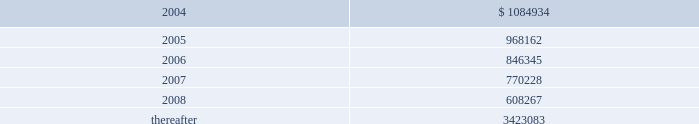Vornado realty trust 77 cash flows the company expects to contribute $ 959000 to the plans in 2004 .
11 .
Leases as lessor : the company leases space to tenants under operating leases .
Most of the leases provide for the payment of fixed base rentals payable monthly in advance .
Shopping center leases provide for the pass-through to tenants of real estate taxes , insurance and maintenance .
Office building leases generally require the tenants to reimburse the company for operating costs and real estate taxes above their base year costs .
Shopping center leases also provide for the payment by the lessee of additional rent based on a percentage of the tenants 2019 sales .
As of december 31 , 2003 , future base rental revenue under non-cancelable operating leases , excluding rents for leases with an original term of less than one year and rents resulting from the exercise of renewal options , is as follows : ( amounts in thousands ) year ending december 31: .
These amounts do not include rentals based on tenants 2019 sales .
These percentage rents approximated $ 3662000 , $ 1832000 , and $ 2157000 , for the years ended december 31 , 2003 , 2002 , and 2001 .
Except for the u.s .
Government , which accounted for 12.7% ( 12.7 % ) of the company 2019s revenue , none of the company 2019s tenants represented more than 10% ( 10 % ) of total revenues for the year ended december 31 , 2003 .
Former bradlees locations property rentals for the year ended december 31 , 2003 , include $ 5000000 of additional rent which , effective december 31 , 2002 , was re-allocated to the former bradlees locations in marlton , turnersville , bensalem and broomall and is payable by stop & shop , pursuant to the master agreement and guaranty , dated may 1 , 1992 .
This amount is in addition to all other rent guaranteed by stop & shop for the former bradlees locations .
On january 8 , 2003 , stop & shop filed a complaint with the united states district court claiming the company has no right to reallocate and therefore continue to collect the $ 5000000 of annual rent from stop & shop because of the expiration of the east brunswick , jersey city , middletown , union and woodbridge leases to which the $ 5000000 of additional rent was previously allocated .
The company believes the additional rent provision of the guaranty expires at the earliest in 2012 and will vigorously oppose stop & shop 2019s complaint .
In february 2003 , koninklijke ahold nv , parent of stop & shop , announced that it overstated its 2002 and 2001 earnings by at least $ 500 million and is under investigation by the u.s .
Justice department and securities and exchange commission .
The company cannot predict what effect , if any , this situation may have on stop & shop 2019s ability to satisfy its obligation under the bradlees guarantees and rent for existing stop & shop leases aggregating approximately $ 10.5 million per annum .
Notes to consolidated financial statements sr-176_fin_l02p53_82v1.qxd 4/8/04 2:42 pm page 77 .
Total percentage rents approximated what in thousands for the years ended december 31 , 2002 and 2001? 
Computations: (1832000 + 2157000)
Answer: 3989000.0. 